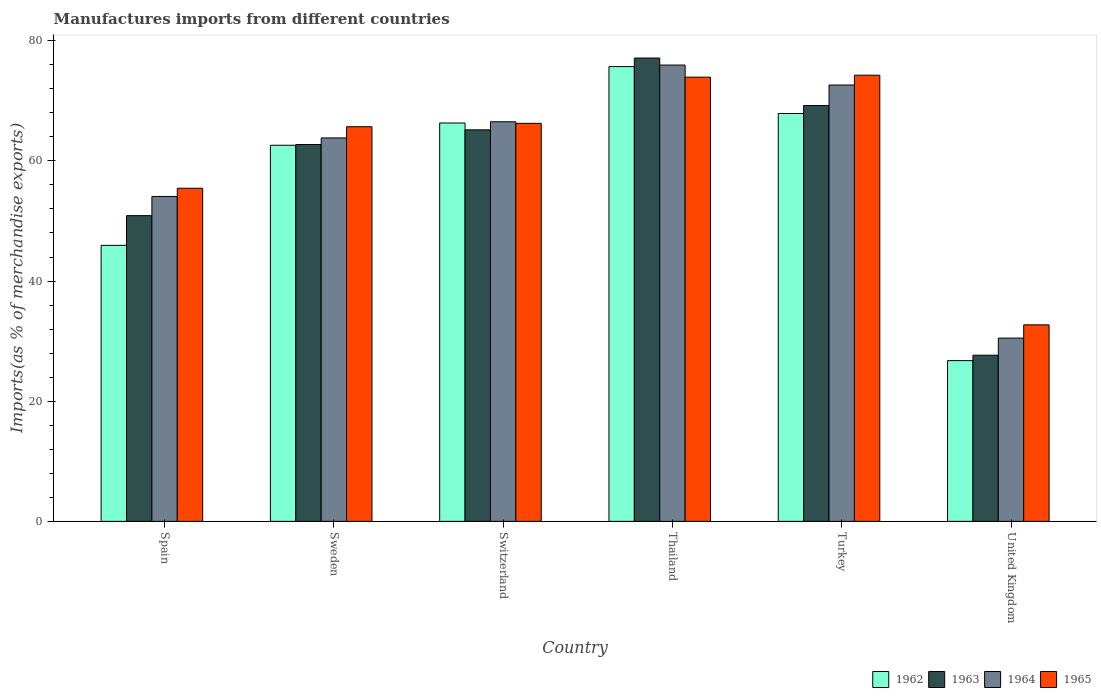How many groups of bars are there?
Provide a succinct answer. 6. Are the number of bars per tick equal to the number of legend labels?
Provide a succinct answer. Yes. How many bars are there on the 4th tick from the left?
Provide a short and direct response. 4. What is the percentage of imports to different countries in 1964 in Turkey?
Provide a succinct answer. 72.62. Across all countries, what is the maximum percentage of imports to different countries in 1963?
Your response must be concise. 77.12. Across all countries, what is the minimum percentage of imports to different countries in 1964?
Provide a short and direct response. 30.5. In which country was the percentage of imports to different countries in 1963 maximum?
Offer a very short reply. Thailand. What is the total percentage of imports to different countries in 1962 in the graph?
Your answer should be very brief. 345.18. What is the difference between the percentage of imports to different countries in 1962 in Spain and that in Thailand?
Your response must be concise. -29.75. What is the difference between the percentage of imports to different countries in 1964 in Sweden and the percentage of imports to different countries in 1965 in United Kingdom?
Your response must be concise. 31.11. What is the average percentage of imports to different countries in 1964 per country?
Provide a short and direct response. 60.58. What is the difference between the percentage of imports to different countries of/in 1963 and percentage of imports to different countries of/in 1962 in Sweden?
Give a very brief answer. 0.12. In how many countries, is the percentage of imports to different countries in 1965 greater than 68 %?
Give a very brief answer. 2. What is the ratio of the percentage of imports to different countries in 1962 in Sweden to that in United Kingdom?
Provide a succinct answer. 2.34. What is the difference between the highest and the second highest percentage of imports to different countries in 1964?
Make the answer very short. 6.12. What is the difference between the highest and the lowest percentage of imports to different countries in 1963?
Your answer should be very brief. 49.46. Is it the case that in every country, the sum of the percentage of imports to different countries in 1964 and percentage of imports to different countries in 1962 is greater than the sum of percentage of imports to different countries in 1965 and percentage of imports to different countries in 1963?
Provide a short and direct response. No. What does the 2nd bar from the left in Thailand represents?
Your answer should be compact. 1963. What does the 1st bar from the right in Turkey represents?
Your response must be concise. 1965. Is it the case that in every country, the sum of the percentage of imports to different countries in 1963 and percentage of imports to different countries in 1965 is greater than the percentage of imports to different countries in 1964?
Give a very brief answer. Yes. Are all the bars in the graph horizontal?
Give a very brief answer. No. What is the difference between two consecutive major ticks on the Y-axis?
Provide a succinct answer. 20. Does the graph contain any zero values?
Your answer should be compact. No. How many legend labels are there?
Provide a succinct answer. 4. What is the title of the graph?
Keep it short and to the point. Manufactures imports from different countries. Does "1960" appear as one of the legend labels in the graph?
Give a very brief answer. No. What is the label or title of the X-axis?
Provide a short and direct response. Country. What is the label or title of the Y-axis?
Make the answer very short. Imports(as % of merchandise exports). What is the Imports(as % of merchandise exports) in 1962 in Spain?
Your answer should be compact. 45.94. What is the Imports(as % of merchandise exports) in 1963 in Spain?
Your response must be concise. 50.88. What is the Imports(as % of merchandise exports) of 1964 in Spain?
Provide a short and direct response. 54.08. What is the Imports(as % of merchandise exports) in 1965 in Spain?
Your answer should be compact. 55.44. What is the Imports(as % of merchandise exports) of 1962 in Sweden?
Offer a very short reply. 62.6. What is the Imports(as % of merchandise exports) in 1963 in Sweden?
Your answer should be very brief. 62.72. What is the Imports(as % of merchandise exports) of 1964 in Sweden?
Your answer should be very brief. 63.82. What is the Imports(as % of merchandise exports) of 1965 in Sweden?
Offer a very short reply. 65.68. What is the Imports(as % of merchandise exports) of 1962 in Switzerland?
Offer a very short reply. 66.31. What is the Imports(as % of merchandise exports) in 1963 in Switzerland?
Make the answer very short. 65.16. What is the Imports(as % of merchandise exports) in 1964 in Switzerland?
Your answer should be compact. 66.51. What is the Imports(as % of merchandise exports) in 1965 in Switzerland?
Your answer should be very brief. 66.24. What is the Imports(as % of merchandise exports) of 1962 in Thailand?
Make the answer very short. 75.69. What is the Imports(as % of merchandise exports) of 1963 in Thailand?
Keep it short and to the point. 77.12. What is the Imports(as % of merchandise exports) of 1964 in Thailand?
Provide a succinct answer. 75.95. What is the Imports(as % of merchandise exports) of 1965 in Thailand?
Give a very brief answer. 73.93. What is the Imports(as % of merchandise exports) in 1962 in Turkey?
Your response must be concise. 67.88. What is the Imports(as % of merchandise exports) in 1963 in Turkey?
Provide a succinct answer. 69.21. What is the Imports(as % of merchandise exports) of 1964 in Turkey?
Offer a very short reply. 72.62. What is the Imports(as % of merchandise exports) of 1965 in Turkey?
Provide a short and direct response. 74.26. What is the Imports(as % of merchandise exports) of 1962 in United Kingdom?
Offer a terse response. 26.76. What is the Imports(as % of merchandise exports) of 1963 in United Kingdom?
Your answer should be compact. 27.66. What is the Imports(as % of merchandise exports) of 1964 in United Kingdom?
Offer a terse response. 30.5. What is the Imports(as % of merchandise exports) in 1965 in United Kingdom?
Your answer should be compact. 32.71. Across all countries, what is the maximum Imports(as % of merchandise exports) in 1962?
Your answer should be compact. 75.69. Across all countries, what is the maximum Imports(as % of merchandise exports) of 1963?
Ensure brevity in your answer.  77.12. Across all countries, what is the maximum Imports(as % of merchandise exports) in 1964?
Give a very brief answer. 75.95. Across all countries, what is the maximum Imports(as % of merchandise exports) of 1965?
Offer a terse response. 74.26. Across all countries, what is the minimum Imports(as % of merchandise exports) in 1962?
Your response must be concise. 26.76. Across all countries, what is the minimum Imports(as % of merchandise exports) of 1963?
Your answer should be compact. 27.66. Across all countries, what is the minimum Imports(as % of merchandise exports) of 1964?
Provide a succinct answer. 30.5. Across all countries, what is the minimum Imports(as % of merchandise exports) of 1965?
Your response must be concise. 32.71. What is the total Imports(as % of merchandise exports) in 1962 in the graph?
Offer a very short reply. 345.18. What is the total Imports(as % of merchandise exports) of 1963 in the graph?
Keep it short and to the point. 352.75. What is the total Imports(as % of merchandise exports) of 1964 in the graph?
Provide a short and direct response. 363.48. What is the total Imports(as % of merchandise exports) in 1965 in the graph?
Provide a succinct answer. 368.27. What is the difference between the Imports(as % of merchandise exports) in 1962 in Spain and that in Sweden?
Give a very brief answer. -16.66. What is the difference between the Imports(as % of merchandise exports) in 1963 in Spain and that in Sweden?
Provide a short and direct response. -11.84. What is the difference between the Imports(as % of merchandise exports) of 1964 in Spain and that in Sweden?
Provide a short and direct response. -9.74. What is the difference between the Imports(as % of merchandise exports) of 1965 in Spain and that in Sweden?
Your answer should be very brief. -10.24. What is the difference between the Imports(as % of merchandise exports) in 1962 in Spain and that in Switzerland?
Offer a very short reply. -20.37. What is the difference between the Imports(as % of merchandise exports) in 1963 in Spain and that in Switzerland?
Ensure brevity in your answer.  -14.28. What is the difference between the Imports(as % of merchandise exports) of 1964 in Spain and that in Switzerland?
Provide a short and direct response. -12.43. What is the difference between the Imports(as % of merchandise exports) of 1965 in Spain and that in Switzerland?
Your answer should be compact. -10.8. What is the difference between the Imports(as % of merchandise exports) of 1962 in Spain and that in Thailand?
Keep it short and to the point. -29.75. What is the difference between the Imports(as % of merchandise exports) of 1963 in Spain and that in Thailand?
Make the answer very short. -26.23. What is the difference between the Imports(as % of merchandise exports) in 1964 in Spain and that in Thailand?
Your answer should be very brief. -21.87. What is the difference between the Imports(as % of merchandise exports) in 1965 in Spain and that in Thailand?
Provide a succinct answer. -18.49. What is the difference between the Imports(as % of merchandise exports) in 1962 in Spain and that in Turkey?
Make the answer very short. -21.94. What is the difference between the Imports(as % of merchandise exports) of 1963 in Spain and that in Turkey?
Make the answer very short. -18.33. What is the difference between the Imports(as % of merchandise exports) in 1964 in Spain and that in Turkey?
Offer a very short reply. -18.54. What is the difference between the Imports(as % of merchandise exports) of 1965 in Spain and that in Turkey?
Give a very brief answer. -18.82. What is the difference between the Imports(as % of merchandise exports) in 1962 in Spain and that in United Kingdom?
Your response must be concise. 19.18. What is the difference between the Imports(as % of merchandise exports) of 1963 in Spain and that in United Kingdom?
Offer a very short reply. 23.23. What is the difference between the Imports(as % of merchandise exports) of 1964 in Spain and that in United Kingdom?
Ensure brevity in your answer.  23.58. What is the difference between the Imports(as % of merchandise exports) in 1965 in Spain and that in United Kingdom?
Make the answer very short. 22.74. What is the difference between the Imports(as % of merchandise exports) in 1962 in Sweden and that in Switzerland?
Offer a very short reply. -3.71. What is the difference between the Imports(as % of merchandise exports) in 1963 in Sweden and that in Switzerland?
Give a very brief answer. -2.44. What is the difference between the Imports(as % of merchandise exports) of 1964 in Sweden and that in Switzerland?
Keep it short and to the point. -2.69. What is the difference between the Imports(as % of merchandise exports) of 1965 in Sweden and that in Switzerland?
Give a very brief answer. -0.56. What is the difference between the Imports(as % of merchandise exports) in 1962 in Sweden and that in Thailand?
Provide a short and direct response. -13.09. What is the difference between the Imports(as % of merchandise exports) of 1963 in Sweden and that in Thailand?
Your answer should be compact. -14.39. What is the difference between the Imports(as % of merchandise exports) in 1964 in Sweden and that in Thailand?
Keep it short and to the point. -12.13. What is the difference between the Imports(as % of merchandise exports) in 1965 in Sweden and that in Thailand?
Your response must be concise. -8.25. What is the difference between the Imports(as % of merchandise exports) in 1962 in Sweden and that in Turkey?
Provide a succinct answer. -5.28. What is the difference between the Imports(as % of merchandise exports) in 1963 in Sweden and that in Turkey?
Ensure brevity in your answer.  -6.49. What is the difference between the Imports(as % of merchandise exports) of 1964 in Sweden and that in Turkey?
Give a very brief answer. -8.81. What is the difference between the Imports(as % of merchandise exports) of 1965 in Sweden and that in Turkey?
Give a very brief answer. -8.58. What is the difference between the Imports(as % of merchandise exports) of 1962 in Sweden and that in United Kingdom?
Provide a succinct answer. 35.84. What is the difference between the Imports(as % of merchandise exports) in 1963 in Sweden and that in United Kingdom?
Provide a succinct answer. 35.07. What is the difference between the Imports(as % of merchandise exports) in 1964 in Sweden and that in United Kingdom?
Ensure brevity in your answer.  33.31. What is the difference between the Imports(as % of merchandise exports) of 1965 in Sweden and that in United Kingdom?
Offer a terse response. 32.98. What is the difference between the Imports(as % of merchandise exports) in 1962 in Switzerland and that in Thailand?
Provide a succinct answer. -9.39. What is the difference between the Imports(as % of merchandise exports) of 1963 in Switzerland and that in Thailand?
Keep it short and to the point. -11.95. What is the difference between the Imports(as % of merchandise exports) in 1964 in Switzerland and that in Thailand?
Offer a terse response. -9.44. What is the difference between the Imports(as % of merchandise exports) of 1965 in Switzerland and that in Thailand?
Your answer should be compact. -7.69. What is the difference between the Imports(as % of merchandise exports) in 1962 in Switzerland and that in Turkey?
Your response must be concise. -1.58. What is the difference between the Imports(as % of merchandise exports) of 1963 in Switzerland and that in Turkey?
Provide a succinct answer. -4.05. What is the difference between the Imports(as % of merchandise exports) in 1964 in Switzerland and that in Turkey?
Your response must be concise. -6.12. What is the difference between the Imports(as % of merchandise exports) in 1965 in Switzerland and that in Turkey?
Your answer should be very brief. -8.02. What is the difference between the Imports(as % of merchandise exports) of 1962 in Switzerland and that in United Kingdom?
Offer a terse response. 39.55. What is the difference between the Imports(as % of merchandise exports) of 1963 in Switzerland and that in United Kingdom?
Ensure brevity in your answer.  37.51. What is the difference between the Imports(as % of merchandise exports) of 1964 in Switzerland and that in United Kingdom?
Your response must be concise. 36.01. What is the difference between the Imports(as % of merchandise exports) in 1965 in Switzerland and that in United Kingdom?
Keep it short and to the point. 33.54. What is the difference between the Imports(as % of merchandise exports) of 1962 in Thailand and that in Turkey?
Provide a succinct answer. 7.81. What is the difference between the Imports(as % of merchandise exports) of 1963 in Thailand and that in Turkey?
Keep it short and to the point. 7.9. What is the difference between the Imports(as % of merchandise exports) of 1964 in Thailand and that in Turkey?
Keep it short and to the point. 3.33. What is the difference between the Imports(as % of merchandise exports) in 1965 in Thailand and that in Turkey?
Offer a very short reply. -0.33. What is the difference between the Imports(as % of merchandise exports) in 1962 in Thailand and that in United Kingdom?
Provide a succinct answer. 48.94. What is the difference between the Imports(as % of merchandise exports) of 1963 in Thailand and that in United Kingdom?
Your answer should be compact. 49.46. What is the difference between the Imports(as % of merchandise exports) of 1964 in Thailand and that in United Kingdom?
Your response must be concise. 45.45. What is the difference between the Imports(as % of merchandise exports) of 1965 in Thailand and that in United Kingdom?
Your response must be concise. 41.22. What is the difference between the Imports(as % of merchandise exports) of 1962 in Turkey and that in United Kingdom?
Your answer should be compact. 41.13. What is the difference between the Imports(as % of merchandise exports) in 1963 in Turkey and that in United Kingdom?
Make the answer very short. 41.56. What is the difference between the Imports(as % of merchandise exports) of 1964 in Turkey and that in United Kingdom?
Offer a very short reply. 42.12. What is the difference between the Imports(as % of merchandise exports) in 1965 in Turkey and that in United Kingdom?
Provide a short and direct response. 41.55. What is the difference between the Imports(as % of merchandise exports) in 1962 in Spain and the Imports(as % of merchandise exports) in 1963 in Sweden?
Ensure brevity in your answer.  -16.78. What is the difference between the Imports(as % of merchandise exports) of 1962 in Spain and the Imports(as % of merchandise exports) of 1964 in Sweden?
Give a very brief answer. -17.88. What is the difference between the Imports(as % of merchandise exports) of 1962 in Spain and the Imports(as % of merchandise exports) of 1965 in Sweden?
Give a very brief answer. -19.74. What is the difference between the Imports(as % of merchandise exports) of 1963 in Spain and the Imports(as % of merchandise exports) of 1964 in Sweden?
Keep it short and to the point. -12.94. What is the difference between the Imports(as % of merchandise exports) in 1963 in Spain and the Imports(as % of merchandise exports) in 1965 in Sweden?
Your response must be concise. -14.8. What is the difference between the Imports(as % of merchandise exports) in 1964 in Spain and the Imports(as % of merchandise exports) in 1965 in Sweden?
Provide a short and direct response. -11.6. What is the difference between the Imports(as % of merchandise exports) in 1962 in Spain and the Imports(as % of merchandise exports) in 1963 in Switzerland?
Offer a very short reply. -19.23. What is the difference between the Imports(as % of merchandise exports) in 1962 in Spain and the Imports(as % of merchandise exports) in 1964 in Switzerland?
Give a very brief answer. -20.57. What is the difference between the Imports(as % of merchandise exports) in 1962 in Spain and the Imports(as % of merchandise exports) in 1965 in Switzerland?
Make the answer very short. -20.31. What is the difference between the Imports(as % of merchandise exports) in 1963 in Spain and the Imports(as % of merchandise exports) in 1964 in Switzerland?
Your answer should be compact. -15.63. What is the difference between the Imports(as % of merchandise exports) of 1963 in Spain and the Imports(as % of merchandise exports) of 1965 in Switzerland?
Give a very brief answer. -15.36. What is the difference between the Imports(as % of merchandise exports) in 1964 in Spain and the Imports(as % of merchandise exports) in 1965 in Switzerland?
Offer a terse response. -12.17. What is the difference between the Imports(as % of merchandise exports) of 1962 in Spain and the Imports(as % of merchandise exports) of 1963 in Thailand?
Give a very brief answer. -31.18. What is the difference between the Imports(as % of merchandise exports) in 1962 in Spain and the Imports(as % of merchandise exports) in 1964 in Thailand?
Give a very brief answer. -30.01. What is the difference between the Imports(as % of merchandise exports) of 1962 in Spain and the Imports(as % of merchandise exports) of 1965 in Thailand?
Your answer should be very brief. -27.99. What is the difference between the Imports(as % of merchandise exports) of 1963 in Spain and the Imports(as % of merchandise exports) of 1964 in Thailand?
Give a very brief answer. -25.07. What is the difference between the Imports(as % of merchandise exports) in 1963 in Spain and the Imports(as % of merchandise exports) in 1965 in Thailand?
Provide a succinct answer. -23.05. What is the difference between the Imports(as % of merchandise exports) in 1964 in Spain and the Imports(as % of merchandise exports) in 1965 in Thailand?
Keep it short and to the point. -19.85. What is the difference between the Imports(as % of merchandise exports) in 1962 in Spain and the Imports(as % of merchandise exports) in 1963 in Turkey?
Give a very brief answer. -23.27. What is the difference between the Imports(as % of merchandise exports) in 1962 in Spain and the Imports(as % of merchandise exports) in 1964 in Turkey?
Provide a succinct answer. -26.68. What is the difference between the Imports(as % of merchandise exports) in 1962 in Spain and the Imports(as % of merchandise exports) in 1965 in Turkey?
Your answer should be very brief. -28.32. What is the difference between the Imports(as % of merchandise exports) of 1963 in Spain and the Imports(as % of merchandise exports) of 1964 in Turkey?
Ensure brevity in your answer.  -21.74. What is the difference between the Imports(as % of merchandise exports) of 1963 in Spain and the Imports(as % of merchandise exports) of 1965 in Turkey?
Your answer should be very brief. -23.38. What is the difference between the Imports(as % of merchandise exports) in 1964 in Spain and the Imports(as % of merchandise exports) in 1965 in Turkey?
Ensure brevity in your answer.  -20.18. What is the difference between the Imports(as % of merchandise exports) in 1962 in Spain and the Imports(as % of merchandise exports) in 1963 in United Kingdom?
Provide a succinct answer. 18.28. What is the difference between the Imports(as % of merchandise exports) of 1962 in Spain and the Imports(as % of merchandise exports) of 1964 in United Kingdom?
Your answer should be very brief. 15.44. What is the difference between the Imports(as % of merchandise exports) in 1962 in Spain and the Imports(as % of merchandise exports) in 1965 in United Kingdom?
Provide a succinct answer. 13.23. What is the difference between the Imports(as % of merchandise exports) of 1963 in Spain and the Imports(as % of merchandise exports) of 1964 in United Kingdom?
Your answer should be very brief. 20.38. What is the difference between the Imports(as % of merchandise exports) of 1963 in Spain and the Imports(as % of merchandise exports) of 1965 in United Kingdom?
Your response must be concise. 18.18. What is the difference between the Imports(as % of merchandise exports) of 1964 in Spain and the Imports(as % of merchandise exports) of 1965 in United Kingdom?
Ensure brevity in your answer.  21.37. What is the difference between the Imports(as % of merchandise exports) in 1962 in Sweden and the Imports(as % of merchandise exports) in 1963 in Switzerland?
Your answer should be very brief. -2.57. What is the difference between the Imports(as % of merchandise exports) of 1962 in Sweden and the Imports(as % of merchandise exports) of 1964 in Switzerland?
Keep it short and to the point. -3.91. What is the difference between the Imports(as % of merchandise exports) in 1962 in Sweden and the Imports(as % of merchandise exports) in 1965 in Switzerland?
Provide a succinct answer. -3.65. What is the difference between the Imports(as % of merchandise exports) of 1963 in Sweden and the Imports(as % of merchandise exports) of 1964 in Switzerland?
Give a very brief answer. -3.78. What is the difference between the Imports(as % of merchandise exports) in 1963 in Sweden and the Imports(as % of merchandise exports) in 1965 in Switzerland?
Provide a short and direct response. -3.52. What is the difference between the Imports(as % of merchandise exports) of 1964 in Sweden and the Imports(as % of merchandise exports) of 1965 in Switzerland?
Make the answer very short. -2.43. What is the difference between the Imports(as % of merchandise exports) of 1962 in Sweden and the Imports(as % of merchandise exports) of 1963 in Thailand?
Keep it short and to the point. -14.52. What is the difference between the Imports(as % of merchandise exports) of 1962 in Sweden and the Imports(as % of merchandise exports) of 1964 in Thailand?
Ensure brevity in your answer.  -13.35. What is the difference between the Imports(as % of merchandise exports) of 1962 in Sweden and the Imports(as % of merchandise exports) of 1965 in Thailand?
Ensure brevity in your answer.  -11.33. What is the difference between the Imports(as % of merchandise exports) of 1963 in Sweden and the Imports(as % of merchandise exports) of 1964 in Thailand?
Your answer should be very brief. -13.23. What is the difference between the Imports(as % of merchandise exports) in 1963 in Sweden and the Imports(as % of merchandise exports) in 1965 in Thailand?
Offer a terse response. -11.21. What is the difference between the Imports(as % of merchandise exports) of 1964 in Sweden and the Imports(as % of merchandise exports) of 1965 in Thailand?
Give a very brief answer. -10.11. What is the difference between the Imports(as % of merchandise exports) in 1962 in Sweden and the Imports(as % of merchandise exports) in 1963 in Turkey?
Your answer should be compact. -6.61. What is the difference between the Imports(as % of merchandise exports) in 1962 in Sweden and the Imports(as % of merchandise exports) in 1964 in Turkey?
Make the answer very short. -10.02. What is the difference between the Imports(as % of merchandise exports) of 1962 in Sweden and the Imports(as % of merchandise exports) of 1965 in Turkey?
Keep it short and to the point. -11.66. What is the difference between the Imports(as % of merchandise exports) in 1963 in Sweden and the Imports(as % of merchandise exports) in 1964 in Turkey?
Offer a terse response. -9.9. What is the difference between the Imports(as % of merchandise exports) in 1963 in Sweden and the Imports(as % of merchandise exports) in 1965 in Turkey?
Provide a short and direct response. -11.54. What is the difference between the Imports(as % of merchandise exports) of 1964 in Sweden and the Imports(as % of merchandise exports) of 1965 in Turkey?
Offer a very short reply. -10.44. What is the difference between the Imports(as % of merchandise exports) in 1962 in Sweden and the Imports(as % of merchandise exports) in 1963 in United Kingdom?
Your answer should be compact. 34.94. What is the difference between the Imports(as % of merchandise exports) in 1962 in Sweden and the Imports(as % of merchandise exports) in 1964 in United Kingdom?
Your answer should be very brief. 32.1. What is the difference between the Imports(as % of merchandise exports) of 1962 in Sweden and the Imports(as % of merchandise exports) of 1965 in United Kingdom?
Provide a succinct answer. 29.89. What is the difference between the Imports(as % of merchandise exports) in 1963 in Sweden and the Imports(as % of merchandise exports) in 1964 in United Kingdom?
Keep it short and to the point. 32.22. What is the difference between the Imports(as % of merchandise exports) in 1963 in Sweden and the Imports(as % of merchandise exports) in 1965 in United Kingdom?
Provide a short and direct response. 30.02. What is the difference between the Imports(as % of merchandise exports) in 1964 in Sweden and the Imports(as % of merchandise exports) in 1965 in United Kingdom?
Ensure brevity in your answer.  31.11. What is the difference between the Imports(as % of merchandise exports) of 1962 in Switzerland and the Imports(as % of merchandise exports) of 1963 in Thailand?
Provide a short and direct response. -10.81. What is the difference between the Imports(as % of merchandise exports) in 1962 in Switzerland and the Imports(as % of merchandise exports) in 1964 in Thailand?
Keep it short and to the point. -9.64. What is the difference between the Imports(as % of merchandise exports) of 1962 in Switzerland and the Imports(as % of merchandise exports) of 1965 in Thailand?
Make the answer very short. -7.63. What is the difference between the Imports(as % of merchandise exports) of 1963 in Switzerland and the Imports(as % of merchandise exports) of 1964 in Thailand?
Your response must be concise. -10.78. What is the difference between the Imports(as % of merchandise exports) of 1963 in Switzerland and the Imports(as % of merchandise exports) of 1965 in Thailand?
Your answer should be compact. -8.77. What is the difference between the Imports(as % of merchandise exports) in 1964 in Switzerland and the Imports(as % of merchandise exports) in 1965 in Thailand?
Provide a succinct answer. -7.42. What is the difference between the Imports(as % of merchandise exports) in 1962 in Switzerland and the Imports(as % of merchandise exports) in 1963 in Turkey?
Give a very brief answer. -2.91. What is the difference between the Imports(as % of merchandise exports) in 1962 in Switzerland and the Imports(as % of merchandise exports) in 1964 in Turkey?
Make the answer very short. -6.32. What is the difference between the Imports(as % of merchandise exports) of 1962 in Switzerland and the Imports(as % of merchandise exports) of 1965 in Turkey?
Offer a terse response. -7.96. What is the difference between the Imports(as % of merchandise exports) of 1963 in Switzerland and the Imports(as % of merchandise exports) of 1964 in Turkey?
Provide a succinct answer. -7.46. What is the difference between the Imports(as % of merchandise exports) in 1963 in Switzerland and the Imports(as % of merchandise exports) in 1965 in Turkey?
Keep it short and to the point. -9.1. What is the difference between the Imports(as % of merchandise exports) in 1964 in Switzerland and the Imports(as % of merchandise exports) in 1965 in Turkey?
Keep it short and to the point. -7.75. What is the difference between the Imports(as % of merchandise exports) in 1962 in Switzerland and the Imports(as % of merchandise exports) in 1963 in United Kingdom?
Ensure brevity in your answer.  38.65. What is the difference between the Imports(as % of merchandise exports) of 1962 in Switzerland and the Imports(as % of merchandise exports) of 1964 in United Kingdom?
Provide a short and direct response. 35.8. What is the difference between the Imports(as % of merchandise exports) of 1962 in Switzerland and the Imports(as % of merchandise exports) of 1965 in United Kingdom?
Keep it short and to the point. 33.6. What is the difference between the Imports(as % of merchandise exports) of 1963 in Switzerland and the Imports(as % of merchandise exports) of 1964 in United Kingdom?
Your answer should be compact. 34.66. What is the difference between the Imports(as % of merchandise exports) of 1963 in Switzerland and the Imports(as % of merchandise exports) of 1965 in United Kingdom?
Your answer should be compact. 32.46. What is the difference between the Imports(as % of merchandise exports) in 1964 in Switzerland and the Imports(as % of merchandise exports) in 1965 in United Kingdom?
Ensure brevity in your answer.  33.8. What is the difference between the Imports(as % of merchandise exports) in 1962 in Thailand and the Imports(as % of merchandise exports) in 1963 in Turkey?
Provide a succinct answer. 6.48. What is the difference between the Imports(as % of merchandise exports) of 1962 in Thailand and the Imports(as % of merchandise exports) of 1964 in Turkey?
Provide a succinct answer. 3.07. What is the difference between the Imports(as % of merchandise exports) of 1962 in Thailand and the Imports(as % of merchandise exports) of 1965 in Turkey?
Keep it short and to the point. 1.43. What is the difference between the Imports(as % of merchandise exports) of 1963 in Thailand and the Imports(as % of merchandise exports) of 1964 in Turkey?
Offer a terse response. 4.49. What is the difference between the Imports(as % of merchandise exports) in 1963 in Thailand and the Imports(as % of merchandise exports) in 1965 in Turkey?
Give a very brief answer. 2.85. What is the difference between the Imports(as % of merchandise exports) in 1964 in Thailand and the Imports(as % of merchandise exports) in 1965 in Turkey?
Ensure brevity in your answer.  1.69. What is the difference between the Imports(as % of merchandise exports) in 1962 in Thailand and the Imports(as % of merchandise exports) in 1963 in United Kingdom?
Keep it short and to the point. 48.04. What is the difference between the Imports(as % of merchandise exports) of 1962 in Thailand and the Imports(as % of merchandise exports) of 1964 in United Kingdom?
Your answer should be compact. 45.19. What is the difference between the Imports(as % of merchandise exports) of 1962 in Thailand and the Imports(as % of merchandise exports) of 1965 in United Kingdom?
Provide a succinct answer. 42.99. What is the difference between the Imports(as % of merchandise exports) of 1963 in Thailand and the Imports(as % of merchandise exports) of 1964 in United Kingdom?
Provide a short and direct response. 46.61. What is the difference between the Imports(as % of merchandise exports) of 1963 in Thailand and the Imports(as % of merchandise exports) of 1965 in United Kingdom?
Give a very brief answer. 44.41. What is the difference between the Imports(as % of merchandise exports) of 1964 in Thailand and the Imports(as % of merchandise exports) of 1965 in United Kingdom?
Provide a succinct answer. 43.24. What is the difference between the Imports(as % of merchandise exports) of 1962 in Turkey and the Imports(as % of merchandise exports) of 1963 in United Kingdom?
Your response must be concise. 40.23. What is the difference between the Imports(as % of merchandise exports) in 1962 in Turkey and the Imports(as % of merchandise exports) in 1964 in United Kingdom?
Your response must be concise. 37.38. What is the difference between the Imports(as % of merchandise exports) in 1962 in Turkey and the Imports(as % of merchandise exports) in 1965 in United Kingdom?
Offer a very short reply. 35.18. What is the difference between the Imports(as % of merchandise exports) of 1963 in Turkey and the Imports(as % of merchandise exports) of 1964 in United Kingdom?
Offer a very short reply. 38.71. What is the difference between the Imports(as % of merchandise exports) in 1963 in Turkey and the Imports(as % of merchandise exports) in 1965 in United Kingdom?
Keep it short and to the point. 36.51. What is the difference between the Imports(as % of merchandise exports) of 1964 in Turkey and the Imports(as % of merchandise exports) of 1965 in United Kingdom?
Provide a succinct answer. 39.92. What is the average Imports(as % of merchandise exports) of 1962 per country?
Offer a very short reply. 57.53. What is the average Imports(as % of merchandise exports) of 1963 per country?
Provide a succinct answer. 58.79. What is the average Imports(as % of merchandise exports) of 1964 per country?
Offer a terse response. 60.58. What is the average Imports(as % of merchandise exports) of 1965 per country?
Provide a succinct answer. 61.38. What is the difference between the Imports(as % of merchandise exports) in 1962 and Imports(as % of merchandise exports) in 1963 in Spain?
Keep it short and to the point. -4.94. What is the difference between the Imports(as % of merchandise exports) in 1962 and Imports(as % of merchandise exports) in 1964 in Spain?
Ensure brevity in your answer.  -8.14. What is the difference between the Imports(as % of merchandise exports) in 1962 and Imports(as % of merchandise exports) in 1965 in Spain?
Your response must be concise. -9.51. What is the difference between the Imports(as % of merchandise exports) of 1963 and Imports(as % of merchandise exports) of 1964 in Spain?
Provide a succinct answer. -3.2. What is the difference between the Imports(as % of merchandise exports) of 1963 and Imports(as % of merchandise exports) of 1965 in Spain?
Provide a succinct answer. -4.56. What is the difference between the Imports(as % of merchandise exports) of 1964 and Imports(as % of merchandise exports) of 1965 in Spain?
Ensure brevity in your answer.  -1.37. What is the difference between the Imports(as % of merchandise exports) of 1962 and Imports(as % of merchandise exports) of 1963 in Sweden?
Your response must be concise. -0.12. What is the difference between the Imports(as % of merchandise exports) of 1962 and Imports(as % of merchandise exports) of 1964 in Sweden?
Give a very brief answer. -1.22. What is the difference between the Imports(as % of merchandise exports) in 1962 and Imports(as % of merchandise exports) in 1965 in Sweden?
Make the answer very short. -3.08. What is the difference between the Imports(as % of merchandise exports) in 1963 and Imports(as % of merchandise exports) in 1964 in Sweden?
Your response must be concise. -1.09. What is the difference between the Imports(as % of merchandise exports) in 1963 and Imports(as % of merchandise exports) in 1965 in Sweden?
Ensure brevity in your answer.  -2.96. What is the difference between the Imports(as % of merchandise exports) of 1964 and Imports(as % of merchandise exports) of 1965 in Sweden?
Ensure brevity in your answer.  -1.87. What is the difference between the Imports(as % of merchandise exports) of 1962 and Imports(as % of merchandise exports) of 1963 in Switzerland?
Your response must be concise. 1.14. What is the difference between the Imports(as % of merchandise exports) of 1962 and Imports(as % of merchandise exports) of 1964 in Switzerland?
Make the answer very short. -0.2. What is the difference between the Imports(as % of merchandise exports) in 1962 and Imports(as % of merchandise exports) in 1965 in Switzerland?
Your answer should be very brief. 0.06. What is the difference between the Imports(as % of merchandise exports) in 1963 and Imports(as % of merchandise exports) in 1964 in Switzerland?
Make the answer very short. -1.34. What is the difference between the Imports(as % of merchandise exports) in 1963 and Imports(as % of merchandise exports) in 1965 in Switzerland?
Provide a short and direct response. -1.08. What is the difference between the Imports(as % of merchandise exports) in 1964 and Imports(as % of merchandise exports) in 1965 in Switzerland?
Your answer should be compact. 0.26. What is the difference between the Imports(as % of merchandise exports) of 1962 and Imports(as % of merchandise exports) of 1963 in Thailand?
Ensure brevity in your answer.  -1.42. What is the difference between the Imports(as % of merchandise exports) in 1962 and Imports(as % of merchandise exports) in 1964 in Thailand?
Provide a succinct answer. -0.26. What is the difference between the Imports(as % of merchandise exports) of 1962 and Imports(as % of merchandise exports) of 1965 in Thailand?
Offer a very short reply. 1.76. What is the difference between the Imports(as % of merchandise exports) of 1963 and Imports(as % of merchandise exports) of 1964 in Thailand?
Offer a very short reply. 1.17. What is the difference between the Imports(as % of merchandise exports) of 1963 and Imports(as % of merchandise exports) of 1965 in Thailand?
Ensure brevity in your answer.  3.18. What is the difference between the Imports(as % of merchandise exports) of 1964 and Imports(as % of merchandise exports) of 1965 in Thailand?
Keep it short and to the point. 2.02. What is the difference between the Imports(as % of merchandise exports) of 1962 and Imports(as % of merchandise exports) of 1963 in Turkey?
Your answer should be very brief. -1.33. What is the difference between the Imports(as % of merchandise exports) of 1962 and Imports(as % of merchandise exports) of 1964 in Turkey?
Give a very brief answer. -4.74. What is the difference between the Imports(as % of merchandise exports) of 1962 and Imports(as % of merchandise exports) of 1965 in Turkey?
Ensure brevity in your answer.  -6.38. What is the difference between the Imports(as % of merchandise exports) in 1963 and Imports(as % of merchandise exports) in 1964 in Turkey?
Give a very brief answer. -3.41. What is the difference between the Imports(as % of merchandise exports) in 1963 and Imports(as % of merchandise exports) in 1965 in Turkey?
Make the answer very short. -5.05. What is the difference between the Imports(as % of merchandise exports) of 1964 and Imports(as % of merchandise exports) of 1965 in Turkey?
Offer a very short reply. -1.64. What is the difference between the Imports(as % of merchandise exports) of 1962 and Imports(as % of merchandise exports) of 1963 in United Kingdom?
Make the answer very short. -0.9. What is the difference between the Imports(as % of merchandise exports) of 1962 and Imports(as % of merchandise exports) of 1964 in United Kingdom?
Your answer should be very brief. -3.75. What is the difference between the Imports(as % of merchandise exports) in 1962 and Imports(as % of merchandise exports) in 1965 in United Kingdom?
Offer a very short reply. -5.95. What is the difference between the Imports(as % of merchandise exports) in 1963 and Imports(as % of merchandise exports) in 1964 in United Kingdom?
Offer a terse response. -2.85. What is the difference between the Imports(as % of merchandise exports) of 1963 and Imports(as % of merchandise exports) of 1965 in United Kingdom?
Provide a short and direct response. -5.05. What is the difference between the Imports(as % of merchandise exports) of 1964 and Imports(as % of merchandise exports) of 1965 in United Kingdom?
Keep it short and to the point. -2.2. What is the ratio of the Imports(as % of merchandise exports) of 1962 in Spain to that in Sweden?
Provide a short and direct response. 0.73. What is the ratio of the Imports(as % of merchandise exports) of 1963 in Spain to that in Sweden?
Offer a terse response. 0.81. What is the ratio of the Imports(as % of merchandise exports) of 1964 in Spain to that in Sweden?
Give a very brief answer. 0.85. What is the ratio of the Imports(as % of merchandise exports) of 1965 in Spain to that in Sweden?
Give a very brief answer. 0.84. What is the ratio of the Imports(as % of merchandise exports) in 1962 in Spain to that in Switzerland?
Offer a very short reply. 0.69. What is the ratio of the Imports(as % of merchandise exports) in 1963 in Spain to that in Switzerland?
Your answer should be compact. 0.78. What is the ratio of the Imports(as % of merchandise exports) in 1964 in Spain to that in Switzerland?
Your answer should be compact. 0.81. What is the ratio of the Imports(as % of merchandise exports) in 1965 in Spain to that in Switzerland?
Your answer should be compact. 0.84. What is the ratio of the Imports(as % of merchandise exports) in 1962 in Spain to that in Thailand?
Provide a short and direct response. 0.61. What is the ratio of the Imports(as % of merchandise exports) of 1963 in Spain to that in Thailand?
Provide a succinct answer. 0.66. What is the ratio of the Imports(as % of merchandise exports) in 1964 in Spain to that in Thailand?
Keep it short and to the point. 0.71. What is the ratio of the Imports(as % of merchandise exports) of 1962 in Spain to that in Turkey?
Make the answer very short. 0.68. What is the ratio of the Imports(as % of merchandise exports) of 1963 in Spain to that in Turkey?
Give a very brief answer. 0.74. What is the ratio of the Imports(as % of merchandise exports) in 1964 in Spain to that in Turkey?
Make the answer very short. 0.74. What is the ratio of the Imports(as % of merchandise exports) in 1965 in Spain to that in Turkey?
Keep it short and to the point. 0.75. What is the ratio of the Imports(as % of merchandise exports) in 1962 in Spain to that in United Kingdom?
Ensure brevity in your answer.  1.72. What is the ratio of the Imports(as % of merchandise exports) of 1963 in Spain to that in United Kingdom?
Keep it short and to the point. 1.84. What is the ratio of the Imports(as % of merchandise exports) in 1964 in Spain to that in United Kingdom?
Your answer should be compact. 1.77. What is the ratio of the Imports(as % of merchandise exports) of 1965 in Spain to that in United Kingdom?
Make the answer very short. 1.7. What is the ratio of the Imports(as % of merchandise exports) of 1962 in Sweden to that in Switzerland?
Provide a short and direct response. 0.94. What is the ratio of the Imports(as % of merchandise exports) in 1963 in Sweden to that in Switzerland?
Your answer should be very brief. 0.96. What is the ratio of the Imports(as % of merchandise exports) of 1964 in Sweden to that in Switzerland?
Give a very brief answer. 0.96. What is the ratio of the Imports(as % of merchandise exports) of 1962 in Sweden to that in Thailand?
Your answer should be very brief. 0.83. What is the ratio of the Imports(as % of merchandise exports) of 1963 in Sweden to that in Thailand?
Your answer should be very brief. 0.81. What is the ratio of the Imports(as % of merchandise exports) in 1964 in Sweden to that in Thailand?
Make the answer very short. 0.84. What is the ratio of the Imports(as % of merchandise exports) of 1965 in Sweden to that in Thailand?
Give a very brief answer. 0.89. What is the ratio of the Imports(as % of merchandise exports) in 1962 in Sweden to that in Turkey?
Keep it short and to the point. 0.92. What is the ratio of the Imports(as % of merchandise exports) of 1963 in Sweden to that in Turkey?
Provide a succinct answer. 0.91. What is the ratio of the Imports(as % of merchandise exports) in 1964 in Sweden to that in Turkey?
Provide a succinct answer. 0.88. What is the ratio of the Imports(as % of merchandise exports) in 1965 in Sweden to that in Turkey?
Your answer should be very brief. 0.88. What is the ratio of the Imports(as % of merchandise exports) of 1962 in Sweden to that in United Kingdom?
Provide a short and direct response. 2.34. What is the ratio of the Imports(as % of merchandise exports) in 1963 in Sweden to that in United Kingdom?
Keep it short and to the point. 2.27. What is the ratio of the Imports(as % of merchandise exports) of 1964 in Sweden to that in United Kingdom?
Provide a succinct answer. 2.09. What is the ratio of the Imports(as % of merchandise exports) of 1965 in Sweden to that in United Kingdom?
Offer a terse response. 2.01. What is the ratio of the Imports(as % of merchandise exports) in 1962 in Switzerland to that in Thailand?
Provide a succinct answer. 0.88. What is the ratio of the Imports(as % of merchandise exports) of 1963 in Switzerland to that in Thailand?
Keep it short and to the point. 0.84. What is the ratio of the Imports(as % of merchandise exports) in 1964 in Switzerland to that in Thailand?
Provide a succinct answer. 0.88. What is the ratio of the Imports(as % of merchandise exports) in 1965 in Switzerland to that in Thailand?
Give a very brief answer. 0.9. What is the ratio of the Imports(as % of merchandise exports) in 1962 in Switzerland to that in Turkey?
Make the answer very short. 0.98. What is the ratio of the Imports(as % of merchandise exports) of 1963 in Switzerland to that in Turkey?
Your answer should be compact. 0.94. What is the ratio of the Imports(as % of merchandise exports) in 1964 in Switzerland to that in Turkey?
Your answer should be compact. 0.92. What is the ratio of the Imports(as % of merchandise exports) in 1965 in Switzerland to that in Turkey?
Provide a succinct answer. 0.89. What is the ratio of the Imports(as % of merchandise exports) of 1962 in Switzerland to that in United Kingdom?
Offer a terse response. 2.48. What is the ratio of the Imports(as % of merchandise exports) in 1963 in Switzerland to that in United Kingdom?
Your answer should be very brief. 2.36. What is the ratio of the Imports(as % of merchandise exports) of 1964 in Switzerland to that in United Kingdom?
Your answer should be compact. 2.18. What is the ratio of the Imports(as % of merchandise exports) of 1965 in Switzerland to that in United Kingdom?
Your response must be concise. 2.03. What is the ratio of the Imports(as % of merchandise exports) in 1962 in Thailand to that in Turkey?
Your answer should be compact. 1.11. What is the ratio of the Imports(as % of merchandise exports) in 1963 in Thailand to that in Turkey?
Keep it short and to the point. 1.11. What is the ratio of the Imports(as % of merchandise exports) of 1964 in Thailand to that in Turkey?
Offer a terse response. 1.05. What is the ratio of the Imports(as % of merchandise exports) of 1962 in Thailand to that in United Kingdom?
Your response must be concise. 2.83. What is the ratio of the Imports(as % of merchandise exports) of 1963 in Thailand to that in United Kingdom?
Make the answer very short. 2.79. What is the ratio of the Imports(as % of merchandise exports) of 1964 in Thailand to that in United Kingdom?
Provide a short and direct response. 2.49. What is the ratio of the Imports(as % of merchandise exports) in 1965 in Thailand to that in United Kingdom?
Offer a terse response. 2.26. What is the ratio of the Imports(as % of merchandise exports) in 1962 in Turkey to that in United Kingdom?
Make the answer very short. 2.54. What is the ratio of the Imports(as % of merchandise exports) in 1963 in Turkey to that in United Kingdom?
Make the answer very short. 2.5. What is the ratio of the Imports(as % of merchandise exports) in 1964 in Turkey to that in United Kingdom?
Offer a very short reply. 2.38. What is the ratio of the Imports(as % of merchandise exports) in 1965 in Turkey to that in United Kingdom?
Give a very brief answer. 2.27. What is the difference between the highest and the second highest Imports(as % of merchandise exports) in 1962?
Provide a short and direct response. 7.81. What is the difference between the highest and the second highest Imports(as % of merchandise exports) in 1963?
Your answer should be compact. 7.9. What is the difference between the highest and the second highest Imports(as % of merchandise exports) in 1964?
Offer a terse response. 3.33. What is the difference between the highest and the second highest Imports(as % of merchandise exports) in 1965?
Keep it short and to the point. 0.33. What is the difference between the highest and the lowest Imports(as % of merchandise exports) in 1962?
Provide a succinct answer. 48.94. What is the difference between the highest and the lowest Imports(as % of merchandise exports) in 1963?
Your response must be concise. 49.46. What is the difference between the highest and the lowest Imports(as % of merchandise exports) of 1964?
Keep it short and to the point. 45.45. What is the difference between the highest and the lowest Imports(as % of merchandise exports) in 1965?
Your answer should be very brief. 41.55. 